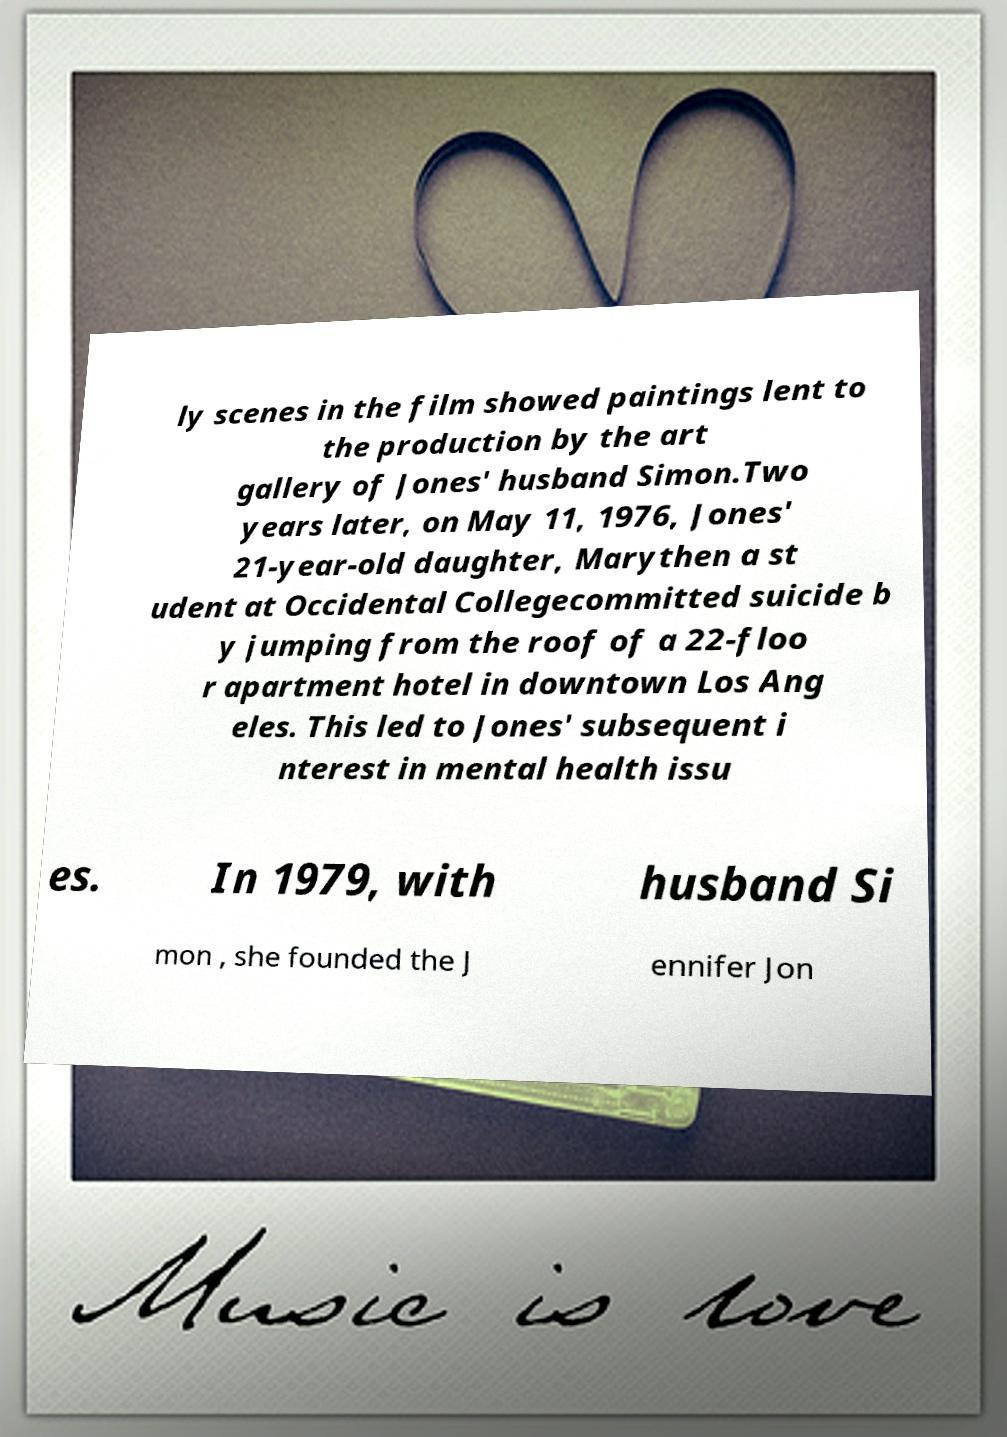Could you assist in decoding the text presented in this image and type it out clearly? ly scenes in the film showed paintings lent to the production by the art gallery of Jones' husband Simon.Two years later, on May 11, 1976, Jones' 21-year-old daughter, Marythen a st udent at Occidental Collegecommitted suicide b y jumping from the roof of a 22-floo r apartment hotel in downtown Los Ang eles. This led to Jones' subsequent i nterest in mental health issu es. In 1979, with husband Si mon , she founded the J ennifer Jon 